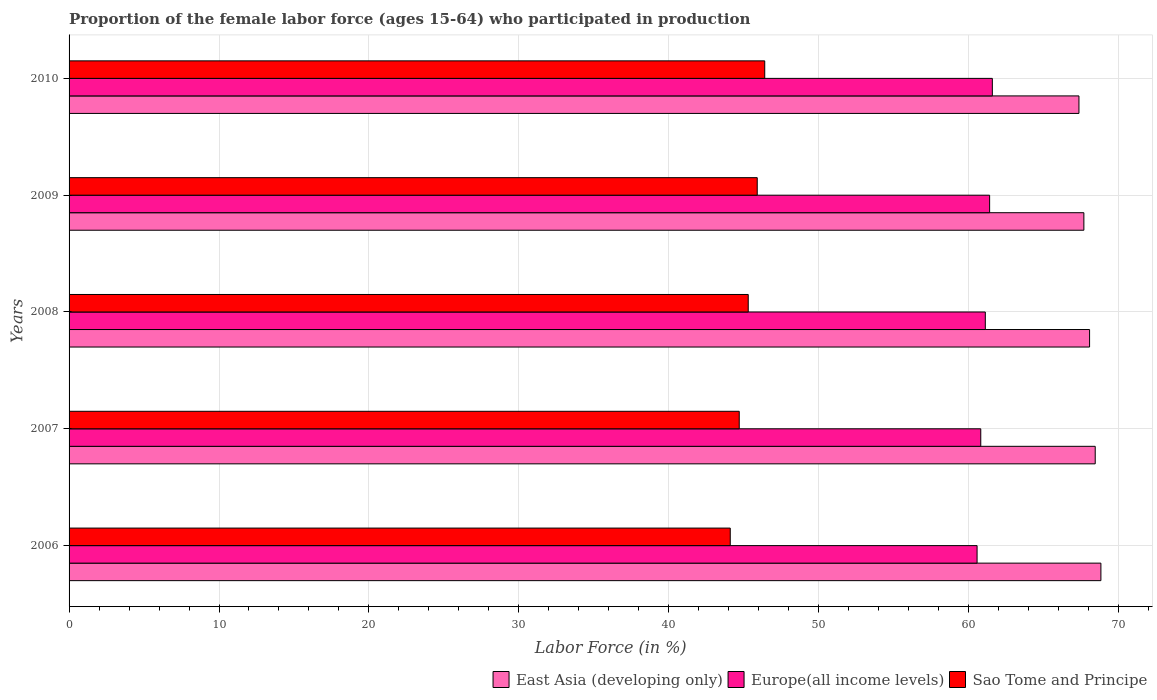How many different coloured bars are there?
Your response must be concise. 3. How many groups of bars are there?
Offer a very short reply. 5. How many bars are there on the 5th tick from the top?
Your response must be concise. 3. What is the proportion of the female labor force who participated in production in Sao Tome and Principe in 2007?
Provide a short and direct response. 44.7. Across all years, what is the maximum proportion of the female labor force who participated in production in East Asia (developing only)?
Keep it short and to the point. 68.82. Across all years, what is the minimum proportion of the female labor force who participated in production in Europe(all income levels)?
Keep it short and to the point. 60.56. In which year was the proportion of the female labor force who participated in production in Europe(all income levels) maximum?
Give a very brief answer. 2010. In which year was the proportion of the female labor force who participated in production in Europe(all income levels) minimum?
Offer a terse response. 2006. What is the total proportion of the female labor force who participated in production in Europe(all income levels) in the graph?
Ensure brevity in your answer.  305.47. What is the difference between the proportion of the female labor force who participated in production in Europe(all income levels) in 2006 and that in 2009?
Keep it short and to the point. -0.84. What is the difference between the proportion of the female labor force who participated in production in Sao Tome and Principe in 2009 and the proportion of the female labor force who participated in production in Europe(all income levels) in 2007?
Provide a succinct answer. -14.91. What is the average proportion of the female labor force who participated in production in Europe(all income levels) per year?
Your answer should be compact. 61.09. In the year 2010, what is the difference between the proportion of the female labor force who participated in production in East Asia (developing only) and proportion of the female labor force who participated in production in Sao Tome and Principe?
Offer a terse response. 20.96. What is the ratio of the proportion of the female labor force who participated in production in Sao Tome and Principe in 2009 to that in 2010?
Your response must be concise. 0.99. Is the proportion of the female labor force who participated in production in East Asia (developing only) in 2006 less than that in 2010?
Offer a very short reply. No. What is the difference between the highest and the second highest proportion of the female labor force who participated in production in Europe(all income levels)?
Provide a succinct answer. 0.18. What is the difference between the highest and the lowest proportion of the female labor force who participated in production in Sao Tome and Principe?
Provide a short and direct response. 2.3. What does the 2nd bar from the top in 2009 represents?
Make the answer very short. Europe(all income levels). What does the 1st bar from the bottom in 2007 represents?
Give a very brief answer. East Asia (developing only). What is the difference between two consecutive major ticks on the X-axis?
Provide a succinct answer. 10. Are the values on the major ticks of X-axis written in scientific E-notation?
Provide a short and direct response. No. Where does the legend appear in the graph?
Give a very brief answer. Bottom right. How many legend labels are there?
Offer a terse response. 3. How are the legend labels stacked?
Give a very brief answer. Horizontal. What is the title of the graph?
Make the answer very short. Proportion of the female labor force (ages 15-64) who participated in production. What is the label or title of the X-axis?
Offer a terse response. Labor Force (in %). What is the label or title of the Y-axis?
Give a very brief answer. Years. What is the Labor Force (in %) in East Asia (developing only) in 2006?
Give a very brief answer. 68.82. What is the Labor Force (in %) of Europe(all income levels) in 2006?
Your answer should be very brief. 60.56. What is the Labor Force (in %) in Sao Tome and Principe in 2006?
Provide a succinct answer. 44.1. What is the Labor Force (in %) of East Asia (developing only) in 2007?
Your answer should be compact. 68.44. What is the Labor Force (in %) of Europe(all income levels) in 2007?
Your answer should be compact. 60.81. What is the Labor Force (in %) in Sao Tome and Principe in 2007?
Keep it short and to the point. 44.7. What is the Labor Force (in %) of East Asia (developing only) in 2008?
Give a very brief answer. 68.07. What is the Labor Force (in %) in Europe(all income levels) in 2008?
Your response must be concise. 61.11. What is the Labor Force (in %) of Sao Tome and Principe in 2008?
Provide a short and direct response. 45.3. What is the Labor Force (in %) of East Asia (developing only) in 2009?
Offer a very short reply. 67.69. What is the Labor Force (in %) in Europe(all income levels) in 2009?
Your answer should be very brief. 61.4. What is the Labor Force (in %) in Sao Tome and Principe in 2009?
Provide a succinct answer. 45.9. What is the Labor Force (in %) of East Asia (developing only) in 2010?
Give a very brief answer. 67.36. What is the Labor Force (in %) of Europe(all income levels) in 2010?
Offer a very short reply. 61.58. What is the Labor Force (in %) in Sao Tome and Principe in 2010?
Your answer should be very brief. 46.4. Across all years, what is the maximum Labor Force (in %) in East Asia (developing only)?
Make the answer very short. 68.82. Across all years, what is the maximum Labor Force (in %) in Europe(all income levels)?
Give a very brief answer. 61.58. Across all years, what is the maximum Labor Force (in %) of Sao Tome and Principe?
Your response must be concise. 46.4. Across all years, what is the minimum Labor Force (in %) in East Asia (developing only)?
Offer a terse response. 67.36. Across all years, what is the minimum Labor Force (in %) of Europe(all income levels)?
Offer a terse response. 60.56. Across all years, what is the minimum Labor Force (in %) in Sao Tome and Principe?
Offer a very short reply. 44.1. What is the total Labor Force (in %) of East Asia (developing only) in the graph?
Provide a succinct answer. 340.38. What is the total Labor Force (in %) in Europe(all income levels) in the graph?
Give a very brief answer. 305.47. What is the total Labor Force (in %) in Sao Tome and Principe in the graph?
Ensure brevity in your answer.  226.4. What is the difference between the Labor Force (in %) of East Asia (developing only) in 2006 and that in 2007?
Offer a terse response. 0.38. What is the difference between the Labor Force (in %) of Europe(all income levels) in 2006 and that in 2007?
Your response must be concise. -0.25. What is the difference between the Labor Force (in %) in East Asia (developing only) in 2006 and that in 2008?
Make the answer very short. 0.75. What is the difference between the Labor Force (in %) of Europe(all income levels) in 2006 and that in 2008?
Make the answer very short. -0.55. What is the difference between the Labor Force (in %) of Sao Tome and Principe in 2006 and that in 2008?
Offer a terse response. -1.2. What is the difference between the Labor Force (in %) of East Asia (developing only) in 2006 and that in 2009?
Ensure brevity in your answer.  1.14. What is the difference between the Labor Force (in %) of Europe(all income levels) in 2006 and that in 2009?
Give a very brief answer. -0.84. What is the difference between the Labor Force (in %) in Sao Tome and Principe in 2006 and that in 2009?
Give a very brief answer. -1.8. What is the difference between the Labor Force (in %) of East Asia (developing only) in 2006 and that in 2010?
Your answer should be compact. 1.46. What is the difference between the Labor Force (in %) in Europe(all income levels) in 2006 and that in 2010?
Make the answer very short. -1.02. What is the difference between the Labor Force (in %) of Sao Tome and Principe in 2006 and that in 2010?
Keep it short and to the point. -2.3. What is the difference between the Labor Force (in %) in East Asia (developing only) in 2007 and that in 2008?
Offer a terse response. 0.38. What is the difference between the Labor Force (in %) of Europe(all income levels) in 2007 and that in 2008?
Give a very brief answer. -0.3. What is the difference between the Labor Force (in %) in East Asia (developing only) in 2007 and that in 2009?
Provide a succinct answer. 0.76. What is the difference between the Labor Force (in %) of Europe(all income levels) in 2007 and that in 2009?
Provide a succinct answer. -0.59. What is the difference between the Labor Force (in %) in Sao Tome and Principe in 2007 and that in 2009?
Your answer should be compact. -1.2. What is the difference between the Labor Force (in %) in East Asia (developing only) in 2007 and that in 2010?
Provide a succinct answer. 1.08. What is the difference between the Labor Force (in %) in Europe(all income levels) in 2007 and that in 2010?
Provide a succinct answer. -0.77. What is the difference between the Labor Force (in %) in Sao Tome and Principe in 2007 and that in 2010?
Your response must be concise. -1.7. What is the difference between the Labor Force (in %) of East Asia (developing only) in 2008 and that in 2009?
Make the answer very short. 0.38. What is the difference between the Labor Force (in %) in Europe(all income levels) in 2008 and that in 2009?
Your response must be concise. -0.29. What is the difference between the Labor Force (in %) in Sao Tome and Principe in 2008 and that in 2009?
Provide a short and direct response. -0.6. What is the difference between the Labor Force (in %) in East Asia (developing only) in 2008 and that in 2010?
Keep it short and to the point. 0.71. What is the difference between the Labor Force (in %) of Europe(all income levels) in 2008 and that in 2010?
Your answer should be compact. -0.47. What is the difference between the Labor Force (in %) of East Asia (developing only) in 2009 and that in 2010?
Give a very brief answer. 0.33. What is the difference between the Labor Force (in %) of Europe(all income levels) in 2009 and that in 2010?
Provide a succinct answer. -0.18. What is the difference between the Labor Force (in %) in East Asia (developing only) in 2006 and the Labor Force (in %) in Europe(all income levels) in 2007?
Give a very brief answer. 8.01. What is the difference between the Labor Force (in %) in East Asia (developing only) in 2006 and the Labor Force (in %) in Sao Tome and Principe in 2007?
Give a very brief answer. 24.12. What is the difference between the Labor Force (in %) in Europe(all income levels) in 2006 and the Labor Force (in %) in Sao Tome and Principe in 2007?
Offer a very short reply. 15.86. What is the difference between the Labor Force (in %) in East Asia (developing only) in 2006 and the Labor Force (in %) in Europe(all income levels) in 2008?
Ensure brevity in your answer.  7.71. What is the difference between the Labor Force (in %) in East Asia (developing only) in 2006 and the Labor Force (in %) in Sao Tome and Principe in 2008?
Give a very brief answer. 23.52. What is the difference between the Labor Force (in %) in Europe(all income levels) in 2006 and the Labor Force (in %) in Sao Tome and Principe in 2008?
Provide a short and direct response. 15.26. What is the difference between the Labor Force (in %) of East Asia (developing only) in 2006 and the Labor Force (in %) of Europe(all income levels) in 2009?
Give a very brief answer. 7.42. What is the difference between the Labor Force (in %) in East Asia (developing only) in 2006 and the Labor Force (in %) in Sao Tome and Principe in 2009?
Give a very brief answer. 22.92. What is the difference between the Labor Force (in %) of Europe(all income levels) in 2006 and the Labor Force (in %) of Sao Tome and Principe in 2009?
Offer a terse response. 14.66. What is the difference between the Labor Force (in %) in East Asia (developing only) in 2006 and the Labor Force (in %) in Europe(all income levels) in 2010?
Provide a succinct answer. 7.24. What is the difference between the Labor Force (in %) in East Asia (developing only) in 2006 and the Labor Force (in %) in Sao Tome and Principe in 2010?
Your response must be concise. 22.42. What is the difference between the Labor Force (in %) of Europe(all income levels) in 2006 and the Labor Force (in %) of Sao Tome and Principe in 2010?
Your answer should be very brief. 14.16. What is the difference between the Labor Force (in %) of East Asia (developing only) in 2007 and the Labor Force (in %) of Europe(all income levels) in 2008?
Provide a succinct answer. 7.33. What is the difference between the Labor Force (in %) in East Asia (developing only) in 2007 and the Labor Force (in %) in Sao Tome and Principe in 2008?
Keep it short and to the point. 23.14. What is the difference between the Labor Force (in %) of Europe(all income levels) in 2007 and the Labor Force (in %) of Sao Tome and Principe in 2008?
Your answer should be compact. 15.51. What is the difference between the Labor Force (in %) in East Asia (developing only) in 2007 and the Labor Force (in %) in Europe(all income levels) in 2009?
Provide a succinct answer. 7.04. What is the difference between the Labor Force (in %) in East Asia (developing only) in 2007 and the Labor Force (in %) in Sao Tome and Principe in 2009?
Your answer should be compact. 22.54. What is the difference between the Labor Force (in %) in Europe(all income levels) in 2007 and the Labor Force (in %) in Sao Tome and Principe in 2009?
Provide a short and direct response. 14.91. What is the difference between the Labor Force (in %) of East Asia (developing only) in 2007 and the Labor Force (in %) of Europe(all income levels) in 2010?
Provide a succinct answer. 6.86. What is the difference between the Labor Force (in %) of East Asia (developing only) in 2007 and the Labor Force (in %) of Sao Tome and Principe in 2010?
Give a very brief answer. 22.04. What is the difference between the Labor Force (in %) in Europe(all income levels) in 2007 and the Labor Force (in %) in Sao Tome and Principe in 2010?
Keep it short and to the point. 14.41. What is the difference between the Labor Force (in %) in East Asia (developing only) in 2008 and the Labor Force (in %) in Europe(all income levels) in 2009?
Your response must be concise. 6.67. What is the difference between the Labor Force (in %) of East Asia (developing only) in 2008 and the Labor Force (in %) of Sao Tome and Principe in 2009?
Give a very brief answer. 22.17. What is the difference between the Labor Force (in %) of Europe(all income levels) in 2008 and the Labor Force (in %) of Sao Tome and Principe in 2009?
Offer a very short reply. 15.21. What is the difference between the Labor Force (in %) of East Asia (developing only) in 2008 and the Labor Force (in %) of Europe(all income levels) in 2010?
Provide a succinct answer. 6.49. What is the difference between the Labor Force (in %) in East Asia (developing only) in 2008 and the Labor Force (in %) in Sao Tome and Principe in 2010?
Provide a short and direct response. 21.67. What is the difference between the Labor Force (in %) in Europe(all income levels) in 2008 and the Labor Force (in %) in Sao Tome and Principe in 2010?
Your answer should be compact. 14.71. What is the difference between the Labor Force (in %) of East Asia (developing only) in 2009 and the Labor Force (in %) of Europe(all income levels) in 2010?
Offer a very short reply. 6.11. What is the difference between the Labor Force (in %) of East Asia (developing only) in 2009 and the Labor Force (in %) of Sao Tome and Principe in 2010?
Provide a succinct answer. 21.29. What is the difference between the Labor Force (in %) in Europe(all income levels) in 2009 and the Labor Force (in %) in Sao Tome and Principe in 2010?
Your answer should be compact. 15. What is the average Labor Force (in %) in East Asia (developing only) per year?
Keep it short and to the point. 68.08. What is the average Labor Force (in %) in Europe(all income levels) per year?
Offer a terse response. 61.09. What is the average Labor Force (in %) of Sao Tome and Principe per year?
Keep it short and to the point. 45.28. In the year 2006, what is the difference between the Labor Force (in %) in East Asia (developing only) and Labor Force (in %) in Europe(all income levels)?
Make the answer very short. 8.26. In the year 2006, what is the difference between the Labor Force (in %) of East Asia (developing only) and Labor Force (in %) of Sao Tome and Principe?
Keep it short and to the point. 24.72. In the year 2006, what is the difference between the Labor Force (in %) of Europe(all income levels) and Labor Force (in %) of Sao Tome and Principe?
Provide a short and direct response. 16.46. In the year 2007, what is the difference between the Labor Force (in %) of East Asia (developing only) and Labor Force (in %) of Europe(all income levels)?
Keep it short and to the point. 7.63. In the year 2007, what is the difference between the Labor Force (in %) in East Asia (developing only) and Labor Force (in %) in Sao Tome and Principe?
Your response must be concise. 23.74. In the year 2007, what is the difference between the Labor Force (in %) of Europe(all income levels) and Labor Force (in %) of Sao Tome and Principe?
Your response must be concise. 16.11. In the year 2008, what is the difference between the Labor Force (in %) of East Asia (developing only) and Labor Force (in %) of Europe(all income levels)?
Provide a short and direct response. 6.95. In the year 2008, what is the difference between the Labor Force (in %) in East Asia (developing only) and Labor Force (in %) in Sao Tome and Principe?
Your response must be concise. 22.77. In the year 2008, what is the difference between the Labor Force (in %) of Europe(all income levels) and Labor Force (in %) of Sao Tome and Principe?
Provide a succinct answer. 15.81. In the year 2009, what is the difference between the Labor Force (in %) in East Asia (developing only) and Labor Force (in %) in Europe(all income levels)?
Give a very brief answer. 6.29. In the year 2009, what is the difference between the Labor Force (in %) of East Asia (developing only) and Labor Force (in %) of Sao Tome and Principe?
Your answer should be very brief. 21.79. In the year 2009, what is the difference between the Labor Force (in %) of Europe(all income levels) and Labor Force (in %) of Sao Tome and Principe?
Keep it short and to the point. 15.5. In the year 2010, what is the difference between the Labor Force (in %) in East Asia (developing only) and Labor Force (in %) in Europe(all income levels)?
Your answer should be compact. 5.78. In the year 2010, what is the difference between the Labor Force (in %) in East Asia (developing only) and Labor Force (in %) in Sao Tome and Principe?
Give a very brief answer. 20.96. In the year 2010, what is the difference between the Labor Force (in %) of Europe(all income levels) and Labor Force (in %) of Sao Tome and Principe?
Keep it short and to the point. 15.18. What is the ratio of the Labor Force (in %) in East Asia (developing only) in 2006 to that in 2007?
Give a very brief answer. 1.01. What is the ratio of the Labor Force (in %) in Sao Tome and Principe in 2006 to that in 2007?
Your response must be concise. 0.99. What is the ratio of the Labor Force (in %) of East Asia (developing only) in 2006 to that in 2008?
Provide a succinct answer. 1.01. What is the ratio of the Labor Force (in %) in Sao Tome and Principe in 2006 to that in 2008?
Ensure brevity in your answer.  0.97. What is the ratio of the Labor Force (in %) of East Asia (developing only) in 2006 to that in 2009?
Offer a very short reply. 1.02. What is the ratio of the Labor Force (in %) of Europe(all income levels) in 2006 to that in 2009?
Your answer should be compact. 0.99. What is the ratio of the Labor Force (in %) of Sao Tome and Principe in 2006 to that in 2009?
Your answer should be compact. 0.96. What is the ratio of the Labor Force (in %) in East Asia (developing only) in 2006 to that in 2010?
Give a very brief answer. 1.02. What is the ratio of the Labor Force (in %) of Europe(all income levels) in 2006 to that in 2010?
Keep it short and to the point. 0.98. What is the ratio of the Labor Force (in %) of Sao Tome and Principe in 2006 to that in 2010?
Provide a short and direct response. 0.95. What is the ratio of the Labor Force (in %) in East Asia (developing only) in 2007 to that in 2008?
Offer a terse response. 1.01. What is the ratio of the Labor Force (in %) in Sao Tome and Principe in 2007 to that in 2008?
Provide a short and direct response. 0.99. What is the ratio of the Labor Force (in %) of East Asia (developing only) in 2007 to that in 2009?
Offer a very short reply. 1.01. What is the ratio of the Labor Force (in %) of Europe(all income levels) in 2007 to that in 2009?
Your answer should be very brief. 0.99. What is the ratio of the Labor Force (in %) in Sao Tome and Principe in 2007 to that in 2009?
Provide a short and direct response. 0.97. What is the ratio of the Labor Force (in %) of East Asia (developing only) in 2007 to that in 2010?
Provide a short and direct response. 1.02. What is the ratio of the Labor Force (in %) in Europe(all income levels) in 2007 to that in 2010?
Your answer should be very brief. 0.99. What is the ratio of the Labor Force (in %) in Sao Tome and Principe in 2007 to that in 2010?
Offer a terse response. 0.96. What is the ratio of the Labor Force (in %) of East Asia (developing only) in 2008 to that in 2009?
Offer a very short reply. 1.01. What is the ratio of the Labor Force (in %) of Sao Tome and Principe in 2008 to that in 2009?
Ensure brevity in your answer.  0.99. What is the ratio of the Labor Force (in %) of East Asia (developing only) in 2008 to that in 2010?
Provide a short and direct response. 1.01. What is the ratio of the Labor Force (in %) in Europe(all income levels) in 2008 to that in 2010?
Offer a very short reply. 0.99. What is the ratio of the Labor Force (in %) of Sao Tome and Principe in 2008 to that in 2010?
Your answer should be compact. 0.98. What is the ratio of the Labor Force (in %) in East Asia (developing only) in 2009 to that in 2010?
Provide a succinct answer. 1. What is the difference between the highest and the second highest Labor Force (in %) in East Asia (developing only)?
Give a very brief answer. 0.38. What is the difference between the highest and the second highest Labor Force (in %) in Europe(all income levels)?
Your answer should be compact. 0.18. What is the difference between the highest and the lowest Labor Force (in %) of East Asia (developing only)?
Keep it short and to the point. 1.46. What is the difference between the highest and the lowest Labor Force (in %) in Europe(all income levels)?
Offer a very short reply. 1.02. What is the difference between the highest and the lowest Labor Force (in %) in Sao Tome and Principe?
Your answer should be very brief. 2.3. 